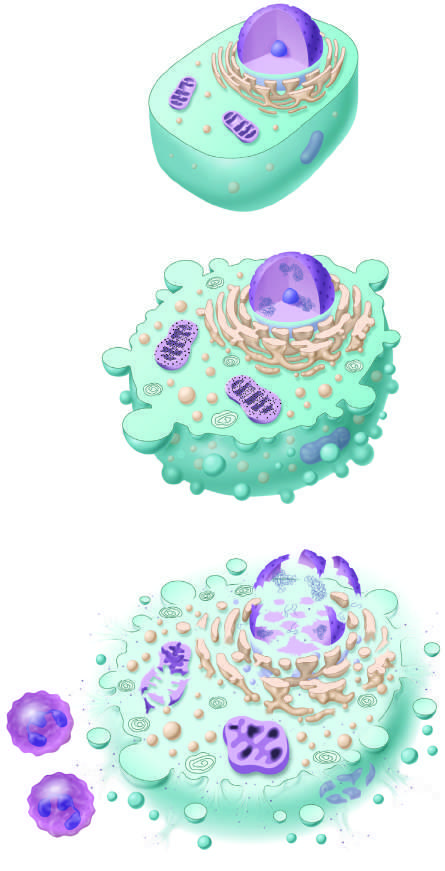what is considered to culminate in necrosis if the injurious stimulus is not removed, by convention?
Answer the question using a single word or phrase. Reversible injury 